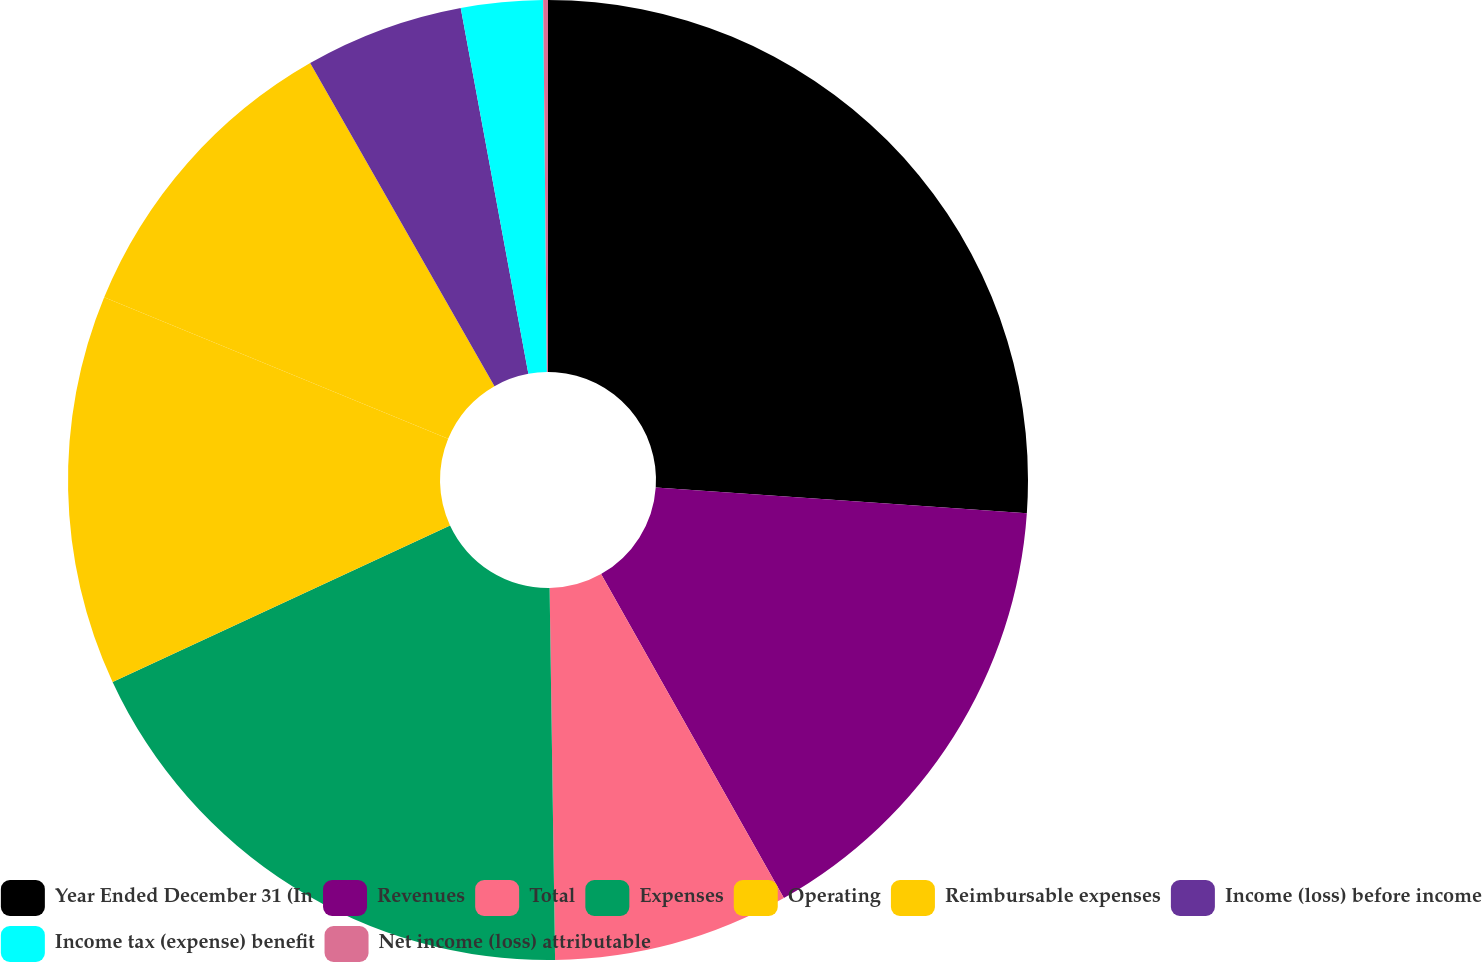<chart> <loc_0><loc_0><loc_500><loc_500><pie_chart><fcel>Year Ended December 31 (In<fcel>Revenues<fcel>Total<fcel>Expenses<fcel>Operating<fcel>Reimbursable expenses<fcel>Income (loss) before income<fcel>Income tax (expense) benefit<fcel>Net income (loss) attributable<nl><fcel>26.1%<fcel>15.72%<fcel>7.94%<fcel>18.32%<fcel>13.13%<fcel>10.53%<fcel>5.34%<fcel>2.75%<fcel>0.16%<nl></chart> 